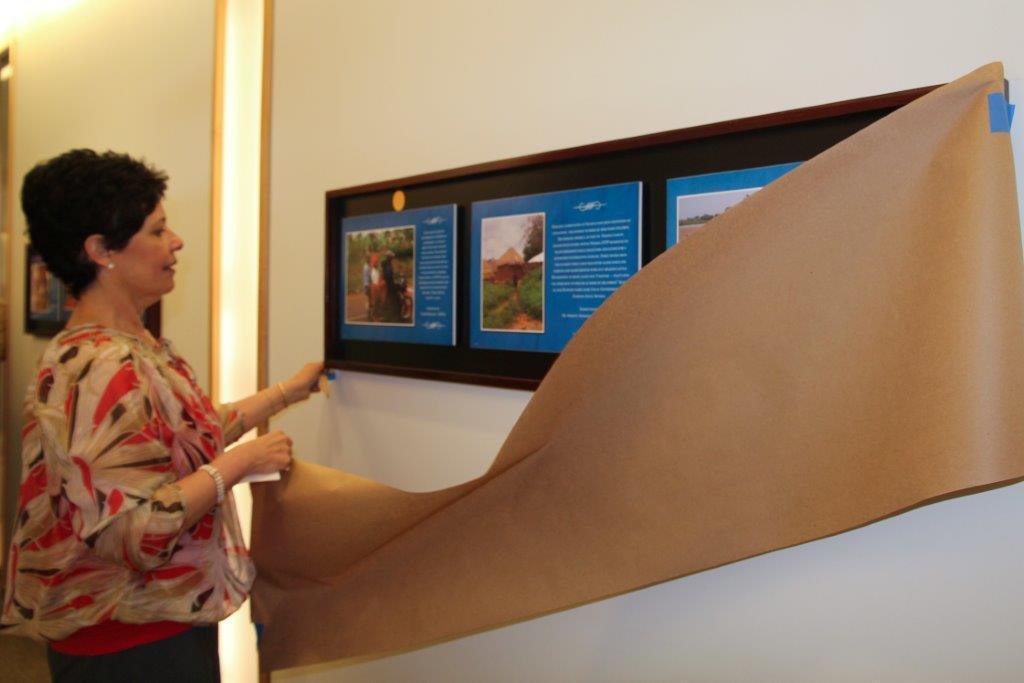Could you give a brief overview of what you see in this image? In this image we can see a woman on the left side and she is having a look at the photo frame which is on the wall. Here we can see the cloth. Here we can see another photo frame on the wall. 